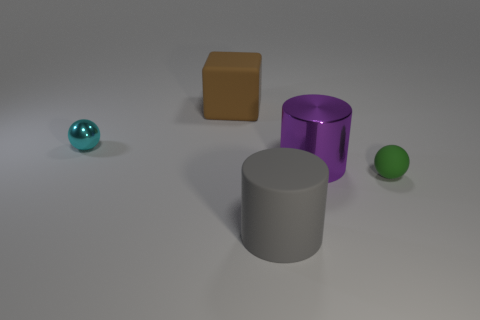Add 4 big green metallic cylinders. How many objects exist? 9 Subtract all cylinders. How many objects are left? 3 Add 2 big blue shiny things. How many big blue shiny things exist? 2 Subtract 0 brown cylinders. How many objects are left? 5 Subtract all tiny green objects. Subtract all metallic cylinders. How many objects are left? 3 Add 5 purple metallic things. How many purple metallic things are left? 6 